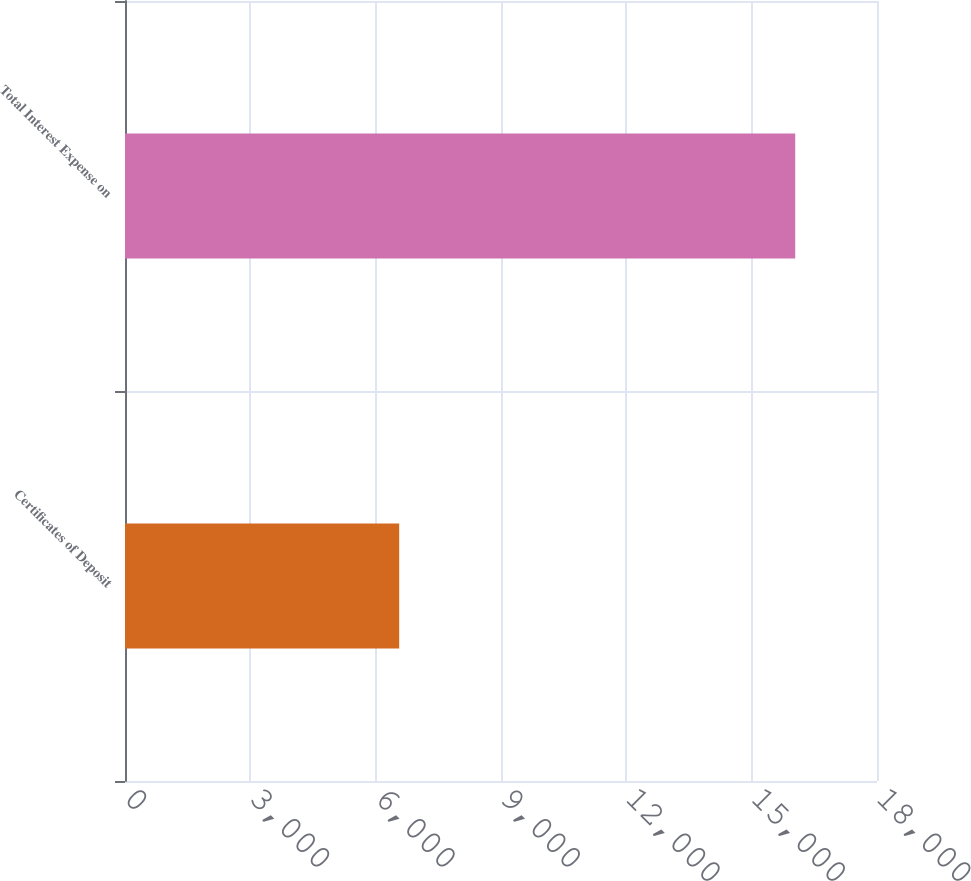Convert chart. <chart><loc_0><loc_0><loc_500><loc_500><bar_chart><fcel>Certificates of Deposit<fcel>Total Interest Expense on<nl><fcel>6563<fcel>16043<nl></chart> 